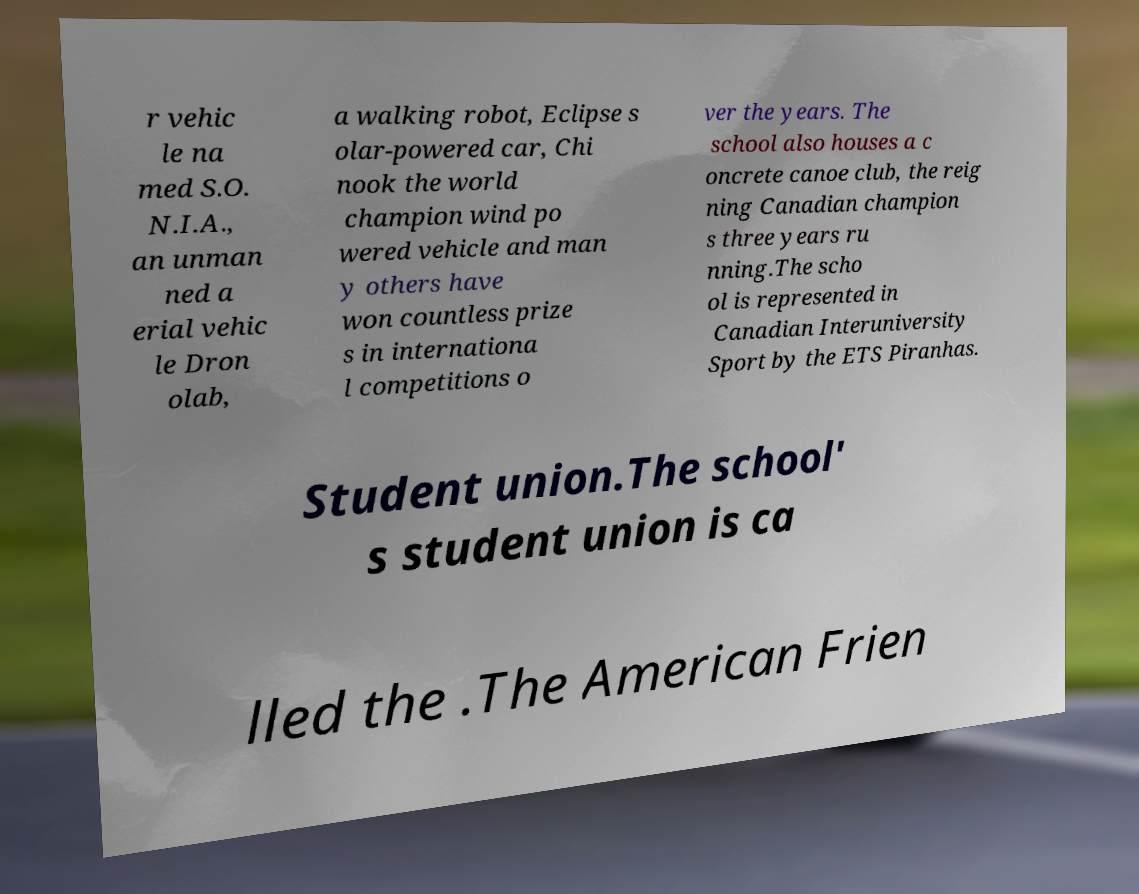What messages or text are displayed in this image? I need them in a readable, typed format. r vehic le na med S.O. N.I.A., an unman ned a erial vehic le Dron olab, a walking robot, Eclipse s olar-powered car, Chi nook the world champion wind po wered vehicle and man y others have won countless prize s in internationa l competitions o ver the years. The school also houses a c oncrete canoe club, the reig ning Canadian champion s three years ru nning.The scho ol is represented in Canadian Interuniversity Sport by the ETS Piranhas. Student union.The school' s student union is ca lled the .The American Frien 